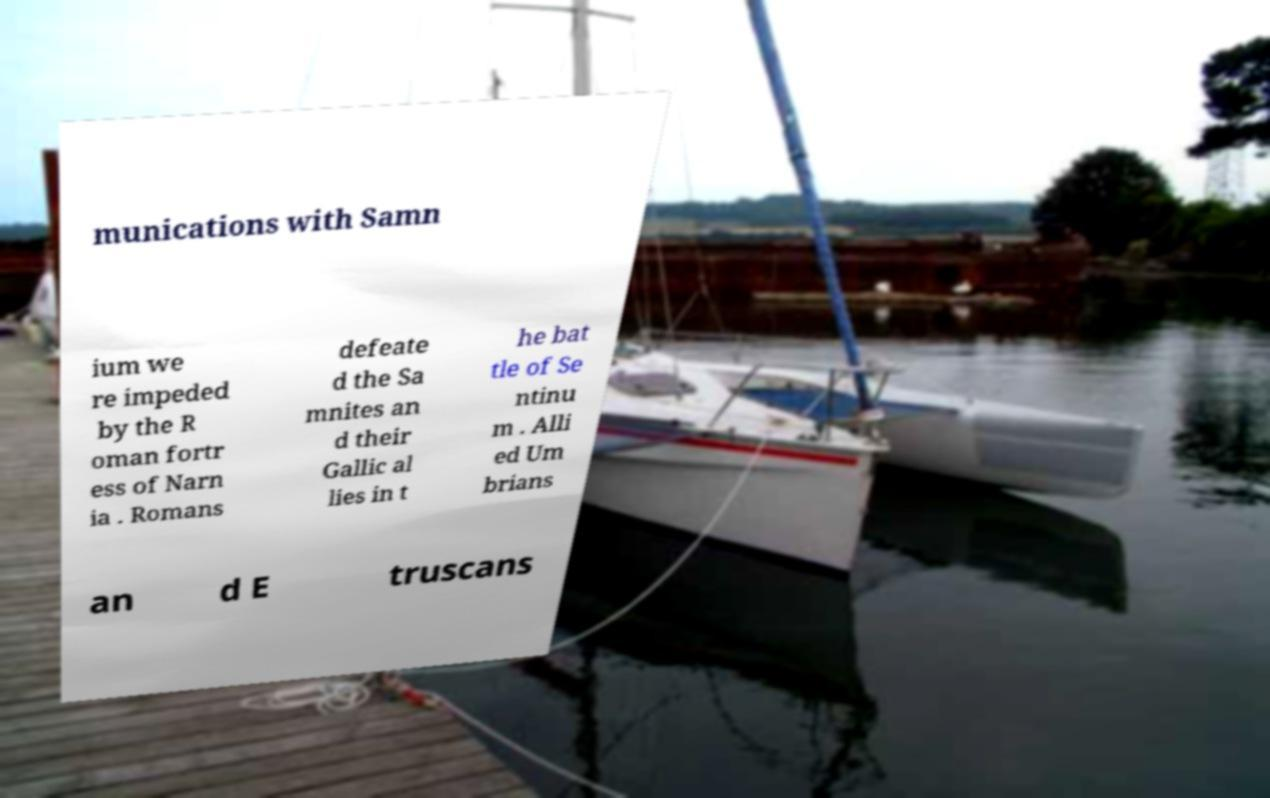There's text embedded in this image that I need extracted. Can you transcribe it verbatim? munications with Samn ium we re impeded by the R oman fortr ess of Narn ia . Romans defeate d the Sa mnites an d their Gallic al lies in t he bat tle of Se ntinu m . Alli ed Um brians an d E truscans 